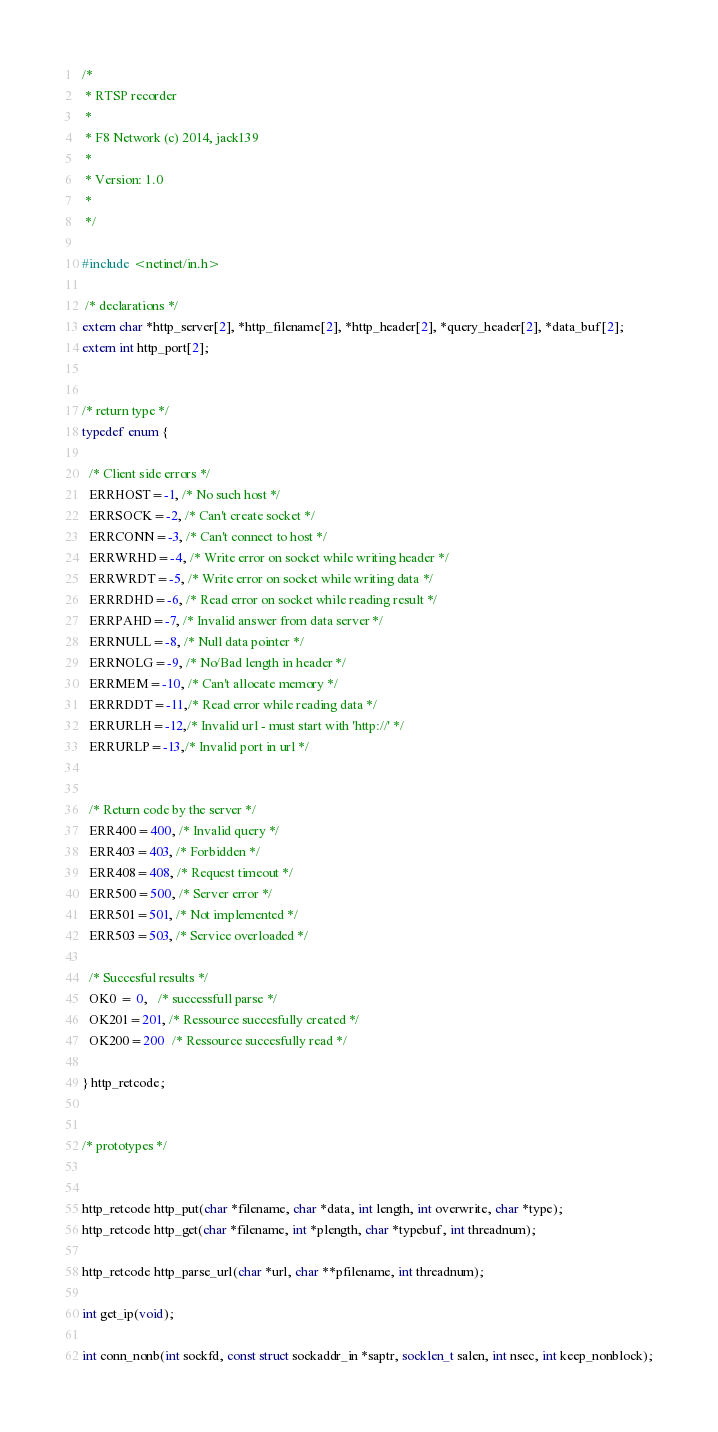<code> <loc_0><loc_0><loc_500><loc_500><_C_>/* 
 * RTSP recorder
 * 
 * F8 Network (c) 2014, jack139
 *
 * Version: 1.0
 *
 */

#include <netinet/in.h>

 /* declarations */
extern char *http_server[2], *http_filename[2], *http_header[2], *query_header[2], *data_buf[2];
extern int http_port[2];


/* return type */
typedef enum {

  /* Client side errors */
  ERRHOST=-1, /* No such host */
  ERRSOCK=-2, /* Can't create socket */
  ERRCONN=-3, /* Can't connect to host */
  ERRWRHD=-4, /* Write error on socket while writing header */
  ERRWRDT=-5, /* Write error on socket while writing data */
  ERRRDHD=-6, /* Read error on socket while reading result */
  ERRPAHD=-7, /* Invalid answer from data server */
  ERRNULL=-8, /* Null data pointer */
  ERRNOLG=-9, /* No/Bad length in header */
  ERRMEM=-10, /* Can't allocate memory */
  ERRRDDT=-11,/* Read error while reading data */
  ERRURLH=-12,/* Invalid url - must start with 'http://' */
  ERRURLP=-13,/* Invalid port in url */
  

  /* Return code by the server */
  ERR400=400, /* Invalid query */
  ERR403=403, /* Forbidden */
  ERR408=408, /* Request timeout */
  ERR500=500, /* Server error */
  ERR501=501, /* Not implemented */
  ERR503=503, /* Service overloaded */

  /* Succesful results */
  OK0 = 0,   /* successfull parse */
  OK201=201, /* Ressource succesfully created */
  OK200=200  /* Ressource succesfully read */

} http_retcode;


/* prototypes */


http_retcode http_put(char *filename, char *data, int length, int overwrite, char *type);
http_retcode http_get(char *filename, int *plength, char *typebuf, int threadnum);

http_retcode http_parse_url(char *url, char **pfilename, int threadnum);

int get_ip(void);

int conn_nonb(int sockfd, const struct sockaddr_in *saptr, socklen_t salen, int nsec, int keep_nonblock);
</code> 